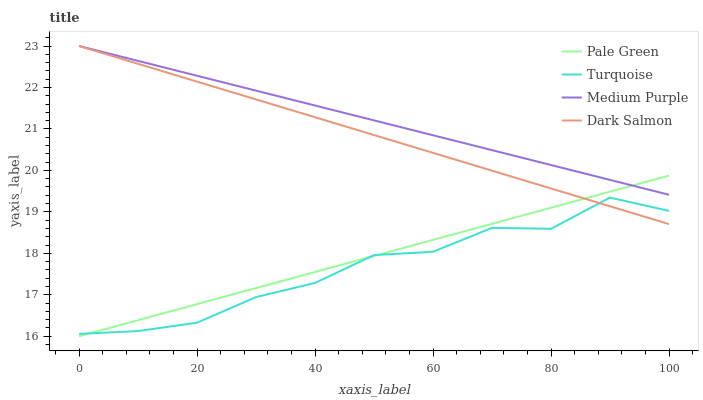Does Turquoise have the minimum area under the curve?
Answer yes or no. Yes. Does Medium Purple have the maximum area under the curve?
Answer yes or no. Yes. Does Pale Green have the minimum area under the curve?
Answer yes or no. No. Does Pale Green have the maximum area under the curve?
Answer yes or no. No. Is Pale Green the smoothest?
Answer yes or no. Yes. Is Turquoise the roughest?
Answer yes or no. Yes. Is Turquoise the smoothest?
Answer yes or no. No. Is Pale Green the roughest?
Answer yes or no. No. Does Pale Green have the lowest value?
Answer yes or no. Yes. Does Turquoise have the lowest value?
Answer yes or no. No. Does Dark Salmon have the highest value?
Answer yes or no. Yes. Does Pale Green have the highest value?
Answer yes or no. No. Is Turquoise less than Medium Purple?
Answer yes or no. Yes. Is Medium Purple greater than Turquoise?
Answer yes or no. Yes. Does Pale Green intersect Medium Purple?
Answer yes or no. Yes. Is Pale Green less than Medium Purple?
Answer yes or no. No. Is Pale Green greater than Medium Purple?
Answer yes or no. No. Does Turquoise intersect Medium Purple?
Answer yes or no. No. 